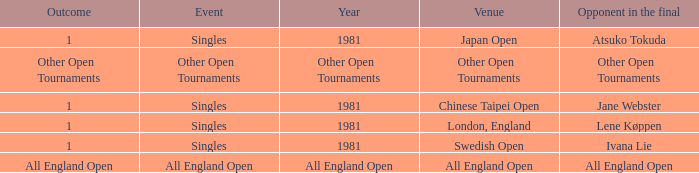What is the Outcome of the Singles Event in London, England? 1.0. 